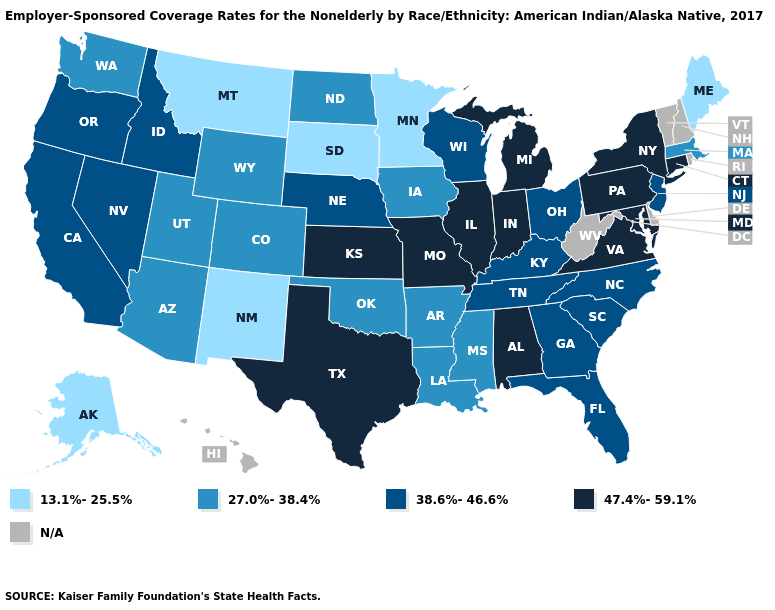Does the first symbol in the legend represent the smallest category?
Be succinct. Yes. Which states hav the highest value in the Northeast?
Give a very brief answer. Connecticut, New York, Pennsylvania. What is the value of Kansas?
Keep it brief. 47.4%-59.1%. Is the legend a continuous bar?
Be succinct. No. Name the states that have a value in the range 38.6%-46.6%?
Concise answer only. California, Florida, Georgia, Idaho, Kentucky, Nebraska, Nevada, New Jersey, North Carolina, Ohio, Oregon, South Carolina, Tennessee, Wisconsin. Among the states that border West Virginia , which have the lowest value?
Write a very short answer. Kentucky, Ohio. Does Kansas have the highest value in the USA?
Be succinct. Yes. What is the value of Nevada?
Give a very brief answer. 38.6%-46.6%. Name the states that have a value in the range 13.1%-25.5%?
Concise answer only. Alaska, Maine, Minnesota, Montana, New Mexico, South Dakota. Among the states that border Washington , which have the highest value?
Write a very short answer. Idaho, Oregon. Name the states that have a value in the range 27.0%-38.4%?
Quick response, please. Arizona, Arkansas, Colorado, Iowa, Louisiana, Massachusetts, Mississippi, North Dakota, Oklahoma, Utah, Washington, Wyoming. Which states have the lowest value in the MidWest?
Give a very brief answer. Minnesota, South Dakota. Name the states that have a value in the range 47.4%-59.1%?
Answer briefly. Alabama, Connecticut, Illinois, Indiana, Kansas, Maryland, Michigan, Missouri, New York, Pennsylvania, Texas, Virginia. 